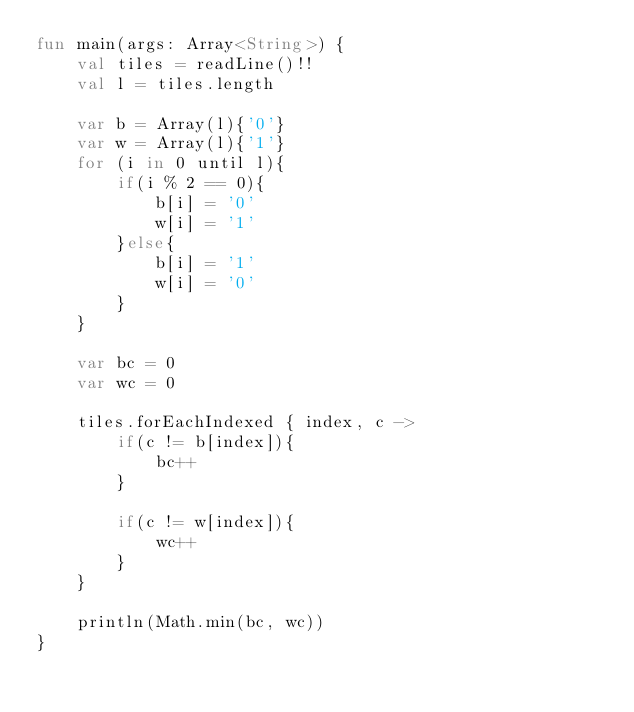<code> <loc_0><loc_0><loc_500><loc_500><_Kotlin_>fun main(args: Array<String>) {
    val tiles = readLine()!!
    val l = tiles.length

    var b = Array(l){'0'}
    var w = Array(l){'1'}
    for (i in 0 until l){
        if(i % 2 == 0){
            b[i] = '0'
            w[i] = '1'
        }else{
            b[i] = '1'
            w[i] = '0'
        }
    }

    var bc = 0
    var wc = 0

    tiles.forEachIndexed { index, c ->
        if(c != b[index]){
            bc++
        }

        if(c != w[index]){
            wc++
        }
    }

    println(Math.min(bc, wc))
}
</code> 